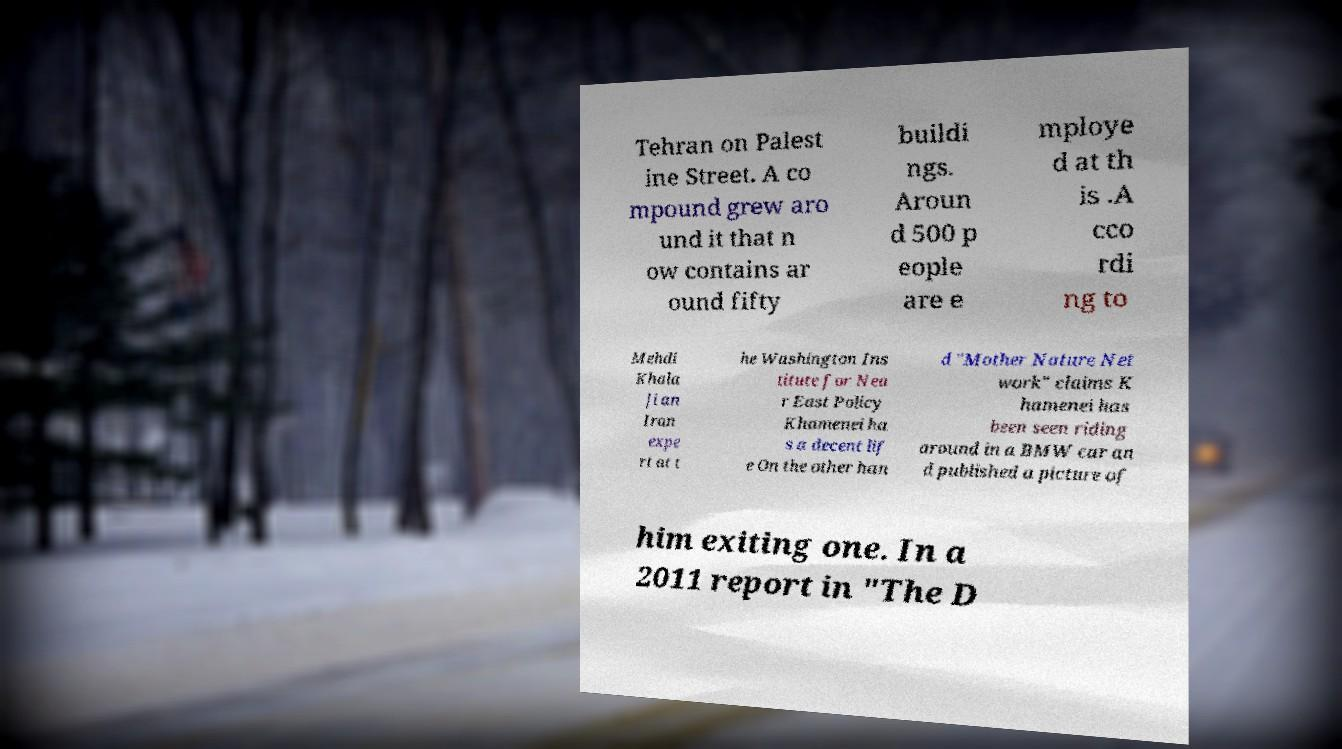What messages or text are displayed in this image? I need them in a readable, typed format. Tehran on Palest ine Street. A co mpound grew aro und it that n ow contains ar ound fifty buildi ngs. Aroun d 500 p eople are e mploye d at th is .A cco rdi ng to Mehdi Khala ji an Iran expe rt at t he Washington Ins titute for Nea r East Policy Khamenei ha s a decent lif e On the other han d "Mother Nature Net work" claims K hamenei has been seen riding around in a BMW car an d published a picture of him exiting one. In a 2011 report in "The D 